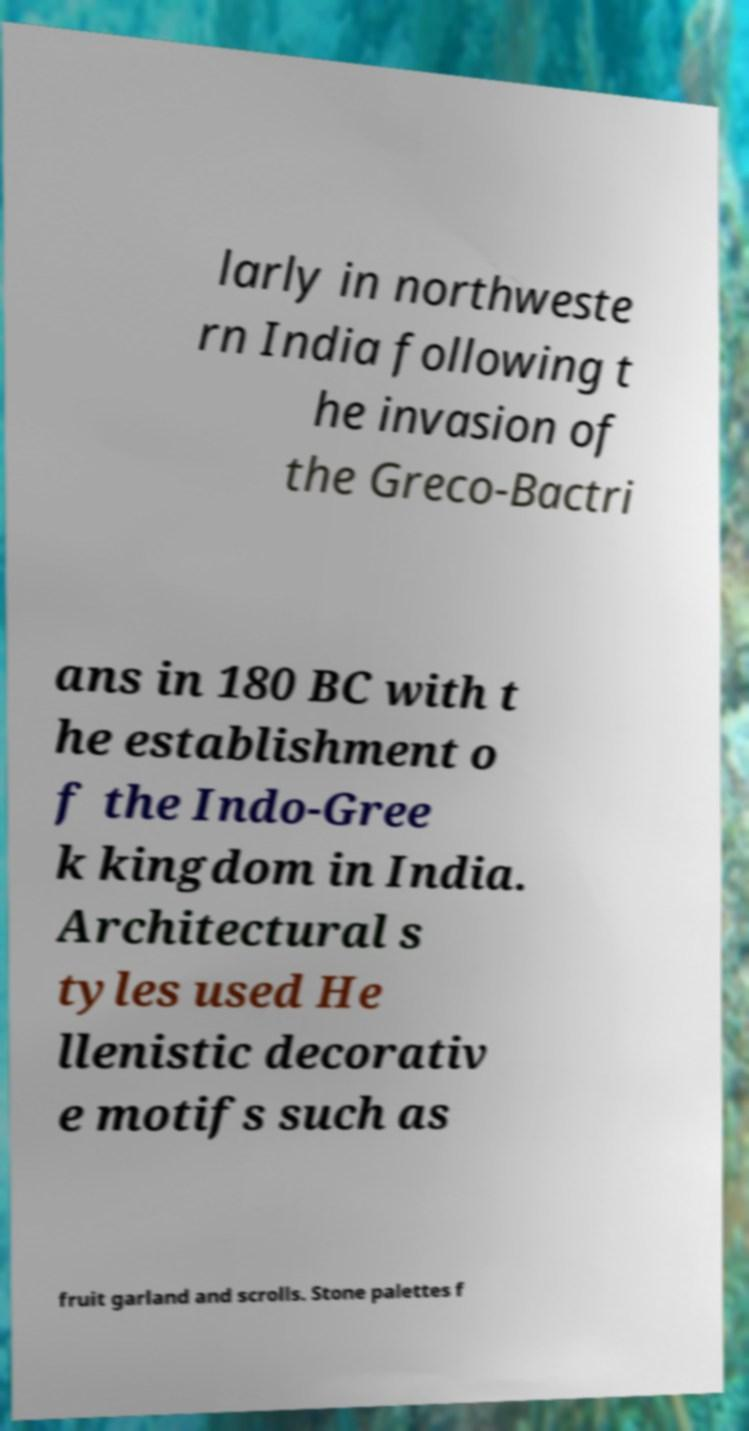There's text embedded in this image that I need extracted. Can you transcribe it verbatim? larly in northweste rn India following t he invasion of the Greco-Bactri ans in 180 BC with t he establishment o f the Indo-Gree k kingdom in India. Architectural s tyles used He llenistic decorativ e motifs such as fruit garland and scrolls. Stone palettes f 